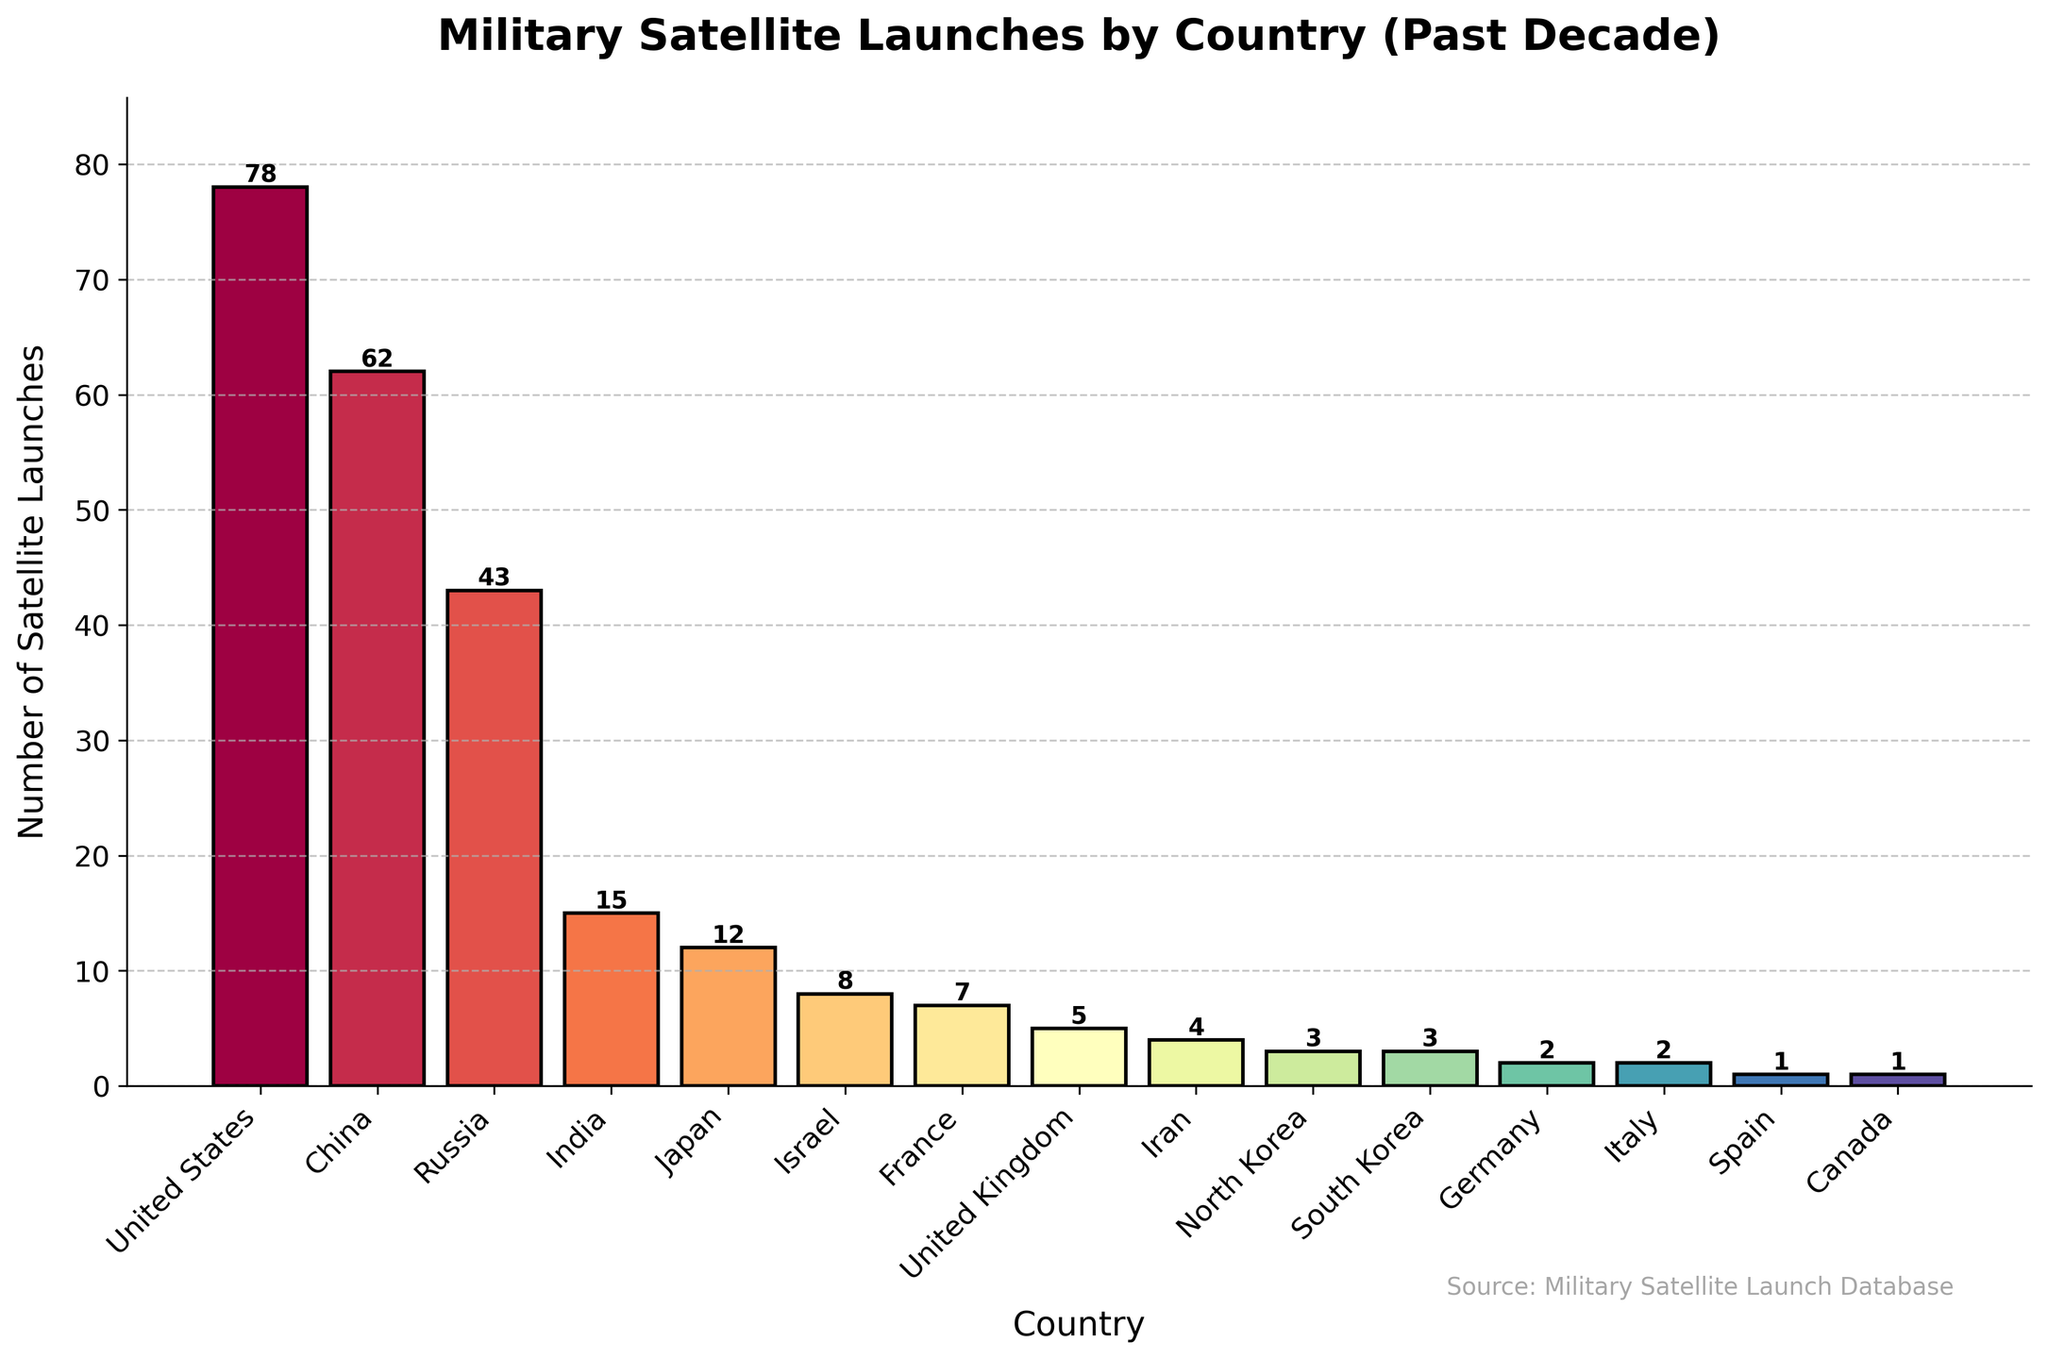Which country has launched the most military satellites in the past decade? The chart shows that the bar for the United States is the highest, indicating it has the greatest number of military satellite launches.
Answer: United States Which two countries have launched a similar number of military satellites, both with fewer than 5 launches? The countries listed with fewer than 5 launches but with similar numbers are North Korea and South Korea, each launching 3 satellites.
Answer: North Korea and South Korea How many more military satellites has China launched compared to Russia? China has launched 62 satellites, whereas Russia has launched 43 satellites. The difference is 62 - 43 = 19.
Answer: 19 What is the total number of military satellite launches by European countries according to the plot? The European countries listed are France (7), United Kingdom (5), Germany (2), Italy (2), and Spain (1). Summing these up: 7 + 5 + 2 + 2 + 1 = 17.
Answer: 17 Which country appears to have the least number of military satellite launches, and how many has it launched? Both Spain and Canada have the shortest bars on the chart, indicating that each country has launched 1 satellite.
Answer: Spain and Canada, 1 each How many countries have launched at least 10 military satellites in the past decade? By observing the bars that reach or exceed 10 launches, the countries are United States (78), China (62), and Russia (43), India (15), and Japan (12). Thus, there are 5 countries.
Answer: 5 What is the combined total of military satellite launches by India, Japan, and Israel? The number of launches for India is 15, Japan is 12, and Israel is 8. Adding these together: 15 + 12 + 8 = 35.
Answer: 35 Are there more countries with fewer than 5 launches or with 5 or more launches? Countries with fewer than 5 launches: Iran (4), North Korea (3), South Korea (3), Germany (2), Italy (2), Spain (1), and Canada (1). Total: 7. Countries with 5 or more launches: United States (78), China (62), Russia (43), India (15), Japan (12), Israel (8), France (7), and United Kingdom (5). Total: 8. There are more countries with 5 or more launches.
Answer: More with 5 or more launches Which country's bar is located between Israel and the United Kingdom in terms of height? Observing the bars, France with 7 launches is between Israel with 8 launches and the United Kingdom with 5 launches.
Answer: France 